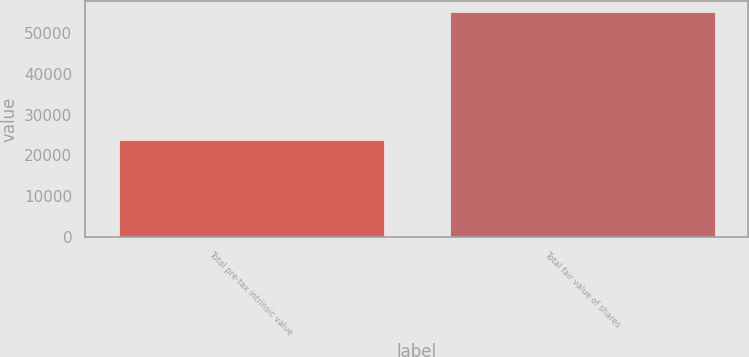Convert chart to OTSL. <chart><loc_0><loc_0><loc_500><loc_500><bar_chart><fcel>Total pre-tax intrinsic value<fcel>Total fair value of shares<nl><fcel>23678<fcel>55186<nl></chart> 